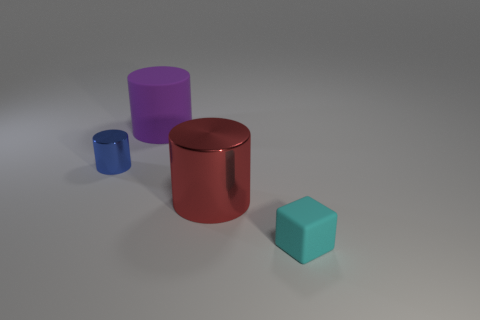Add 1 big red things. How many objects exist? 5 Subtract 1 purple cylinders. How many objects are left? 3 Subtract all cylinders. How many objects are left? 1 Subtract 1 cubes. How many cubes are left? 0 Subtract all brown blocks. Subtract all brown cylinders. How many blocks are left? 1 Subtract all blue cubes. How many green cylinders are left? 0 Subtract all big metal objects. Subtract all rubber blocks. How many objects are left? 2 Add 4 cyan things. How many cyan things are left? 5 Add 1 big red metallic objects. How many big red metallic objects exist? 2 Subtract all red cylinders. How many cylinders are left? 2 